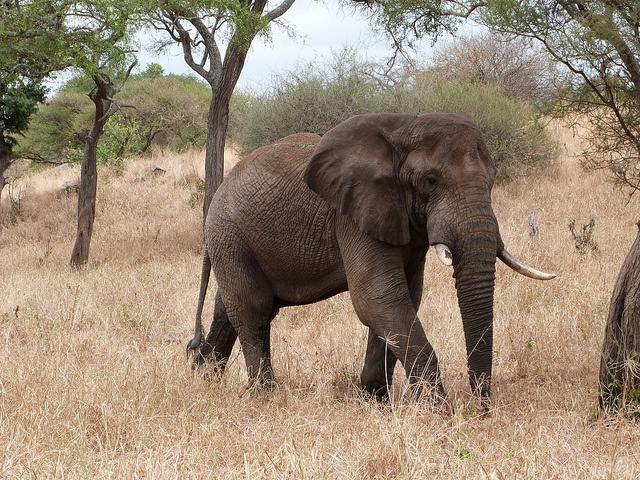Describe the objects in this image and their specific colors. I can see a elephant in gray, black, and maroon tones in this image. 